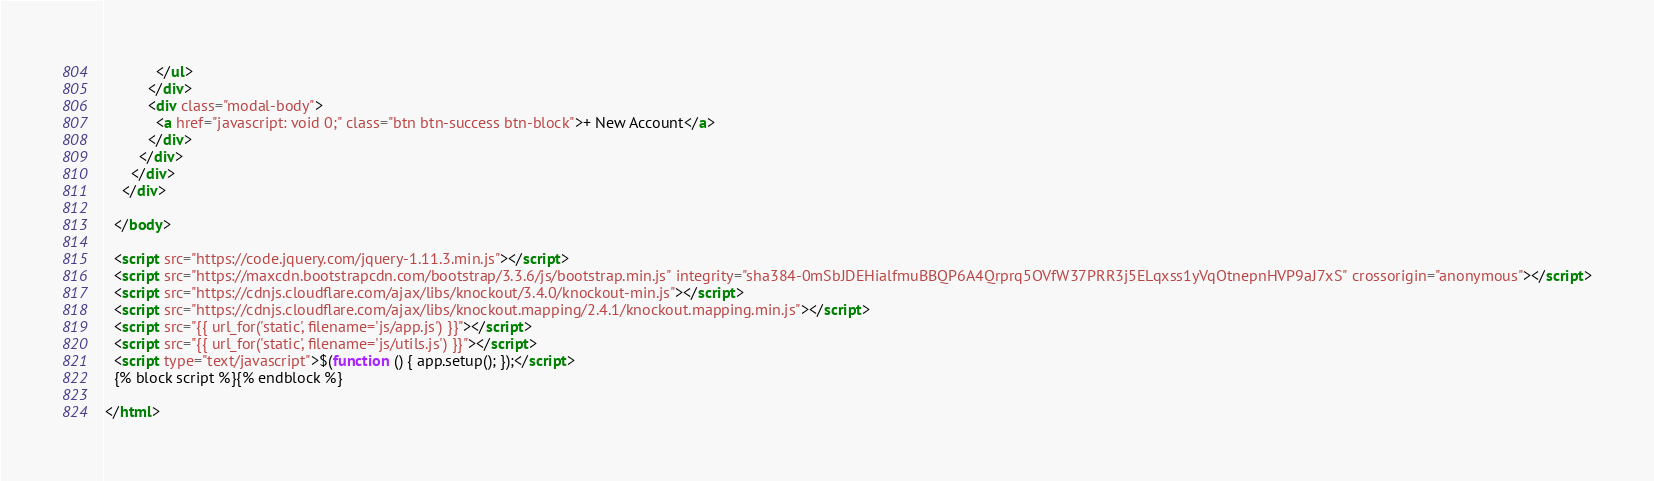Convert code to text. <code><loc_0><loc_0><loc_500><loc_500><_HTML_>            </ul>
          </div>
          <div class="modal-body">
            <a href="javascript: void 0;" class="btn btn-success btn-block">+ New Account</a>
          </div>
        </div>
      </div>
    </div>

  </body>

  <script src="https://code.jquery.com/jquery-1.11.3.min.js"></script>
  <script src="https://maxcdn.bootstrapcdn.com/bootstrap/3.3.6/js/bootstrap.min.js" integrity="sha384-0mSbJDEHialfmuBBQP6A4Qrprq5OVfW37PRR3j5ELqxss1yVqOtnepnHVP9aJ7xS" crossorigin="anonymous"></script>
  <script src="https://cdnjs.cloudflare.com/ajax/libs/knockout/3.4.0/knockout-min.js"></script>
  <script src="https://cdnjs.cloudflare.com/ajax/libs/knockout.mapping/2.4.1/knockout.mapping.min.js"></script>
  <script src="{{ url_for('static', filename='js/app.js') }}"></script>
  <script src="{{ url_for('static', filename='js/utils.js') }}"></script>
  <script type="text/javascript">$(function () { app.setup(); });</script>
  {% block script %}{% endblock %}

</html>
</code> 